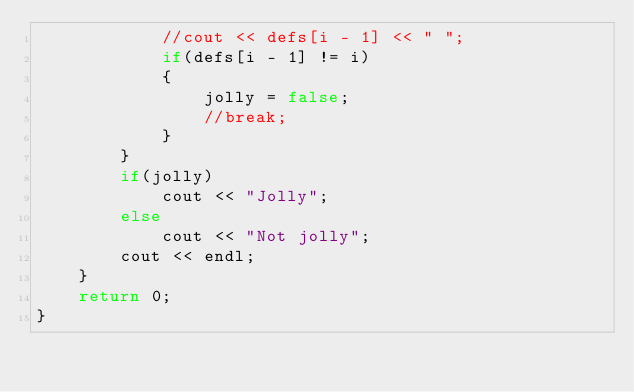Convert code to text. <code><loc_0><loc_0><loc_500><loc_500><_C++_>            //cout << defs[i - 1] << " ";
            if(defs[i - 1] != i)
            {
                jolly = false;
                //break;
            }
        }
        if(jolly)
            cout << "Jolly";
        else
            cout << "Not jolly";
        cout << endl;
    }
    return 0;
}
</code> 